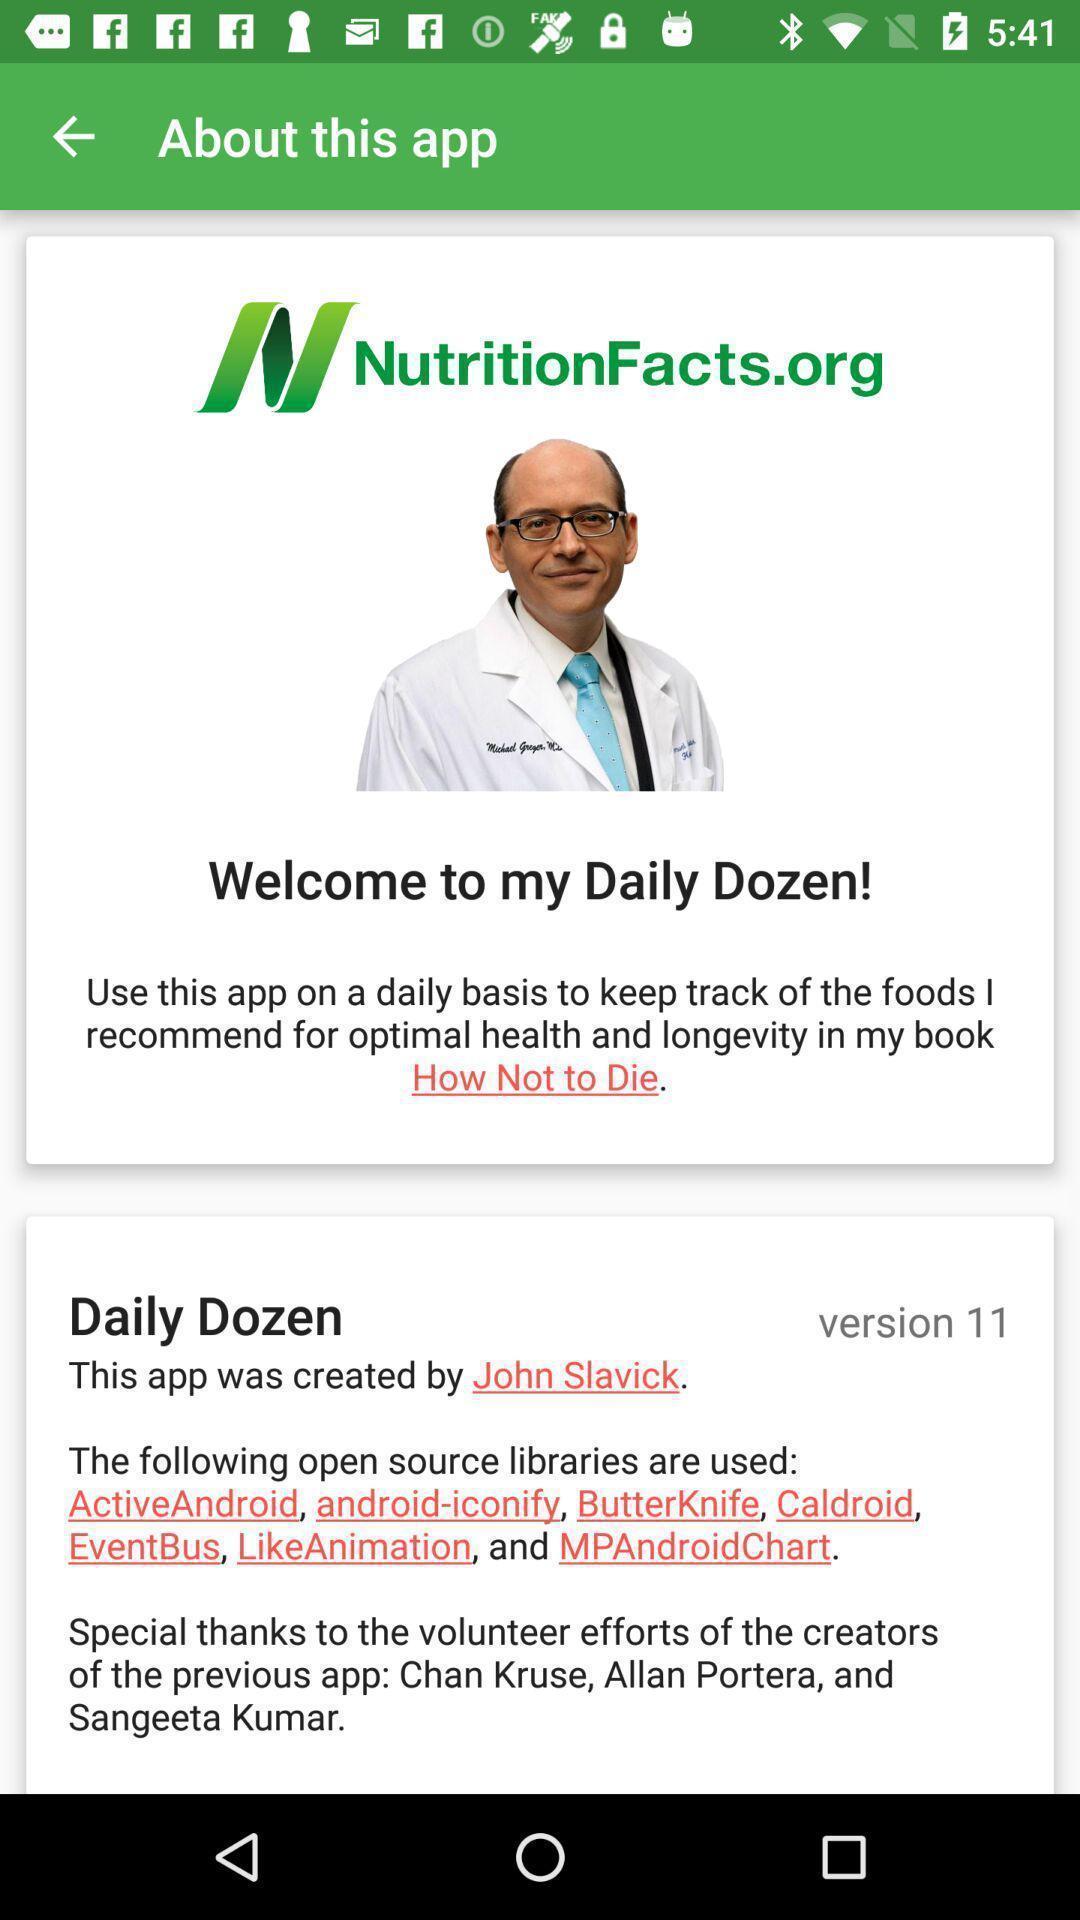Explain the elements present in this screenshot. Screen page of an lifestyle application. 